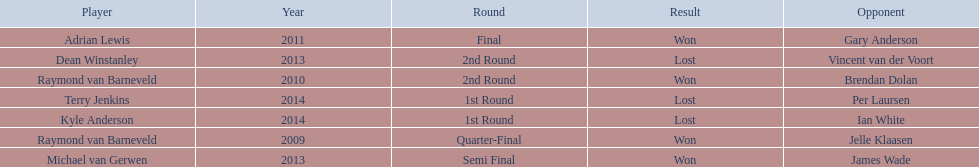Who were all the players? Raymond van Barneveld, Raymond van Barneveld, Adrian Lewis, Dean Winstanley, Michael van Gerwen, Terry Jenkins, Kyle Anderson. Which of these played in 2014? Terry Jenkins, Kyle Anderson. Who were their opponents? Per Laursen, Ian White. Which of these beat terry jenkins? Per Laursen. 